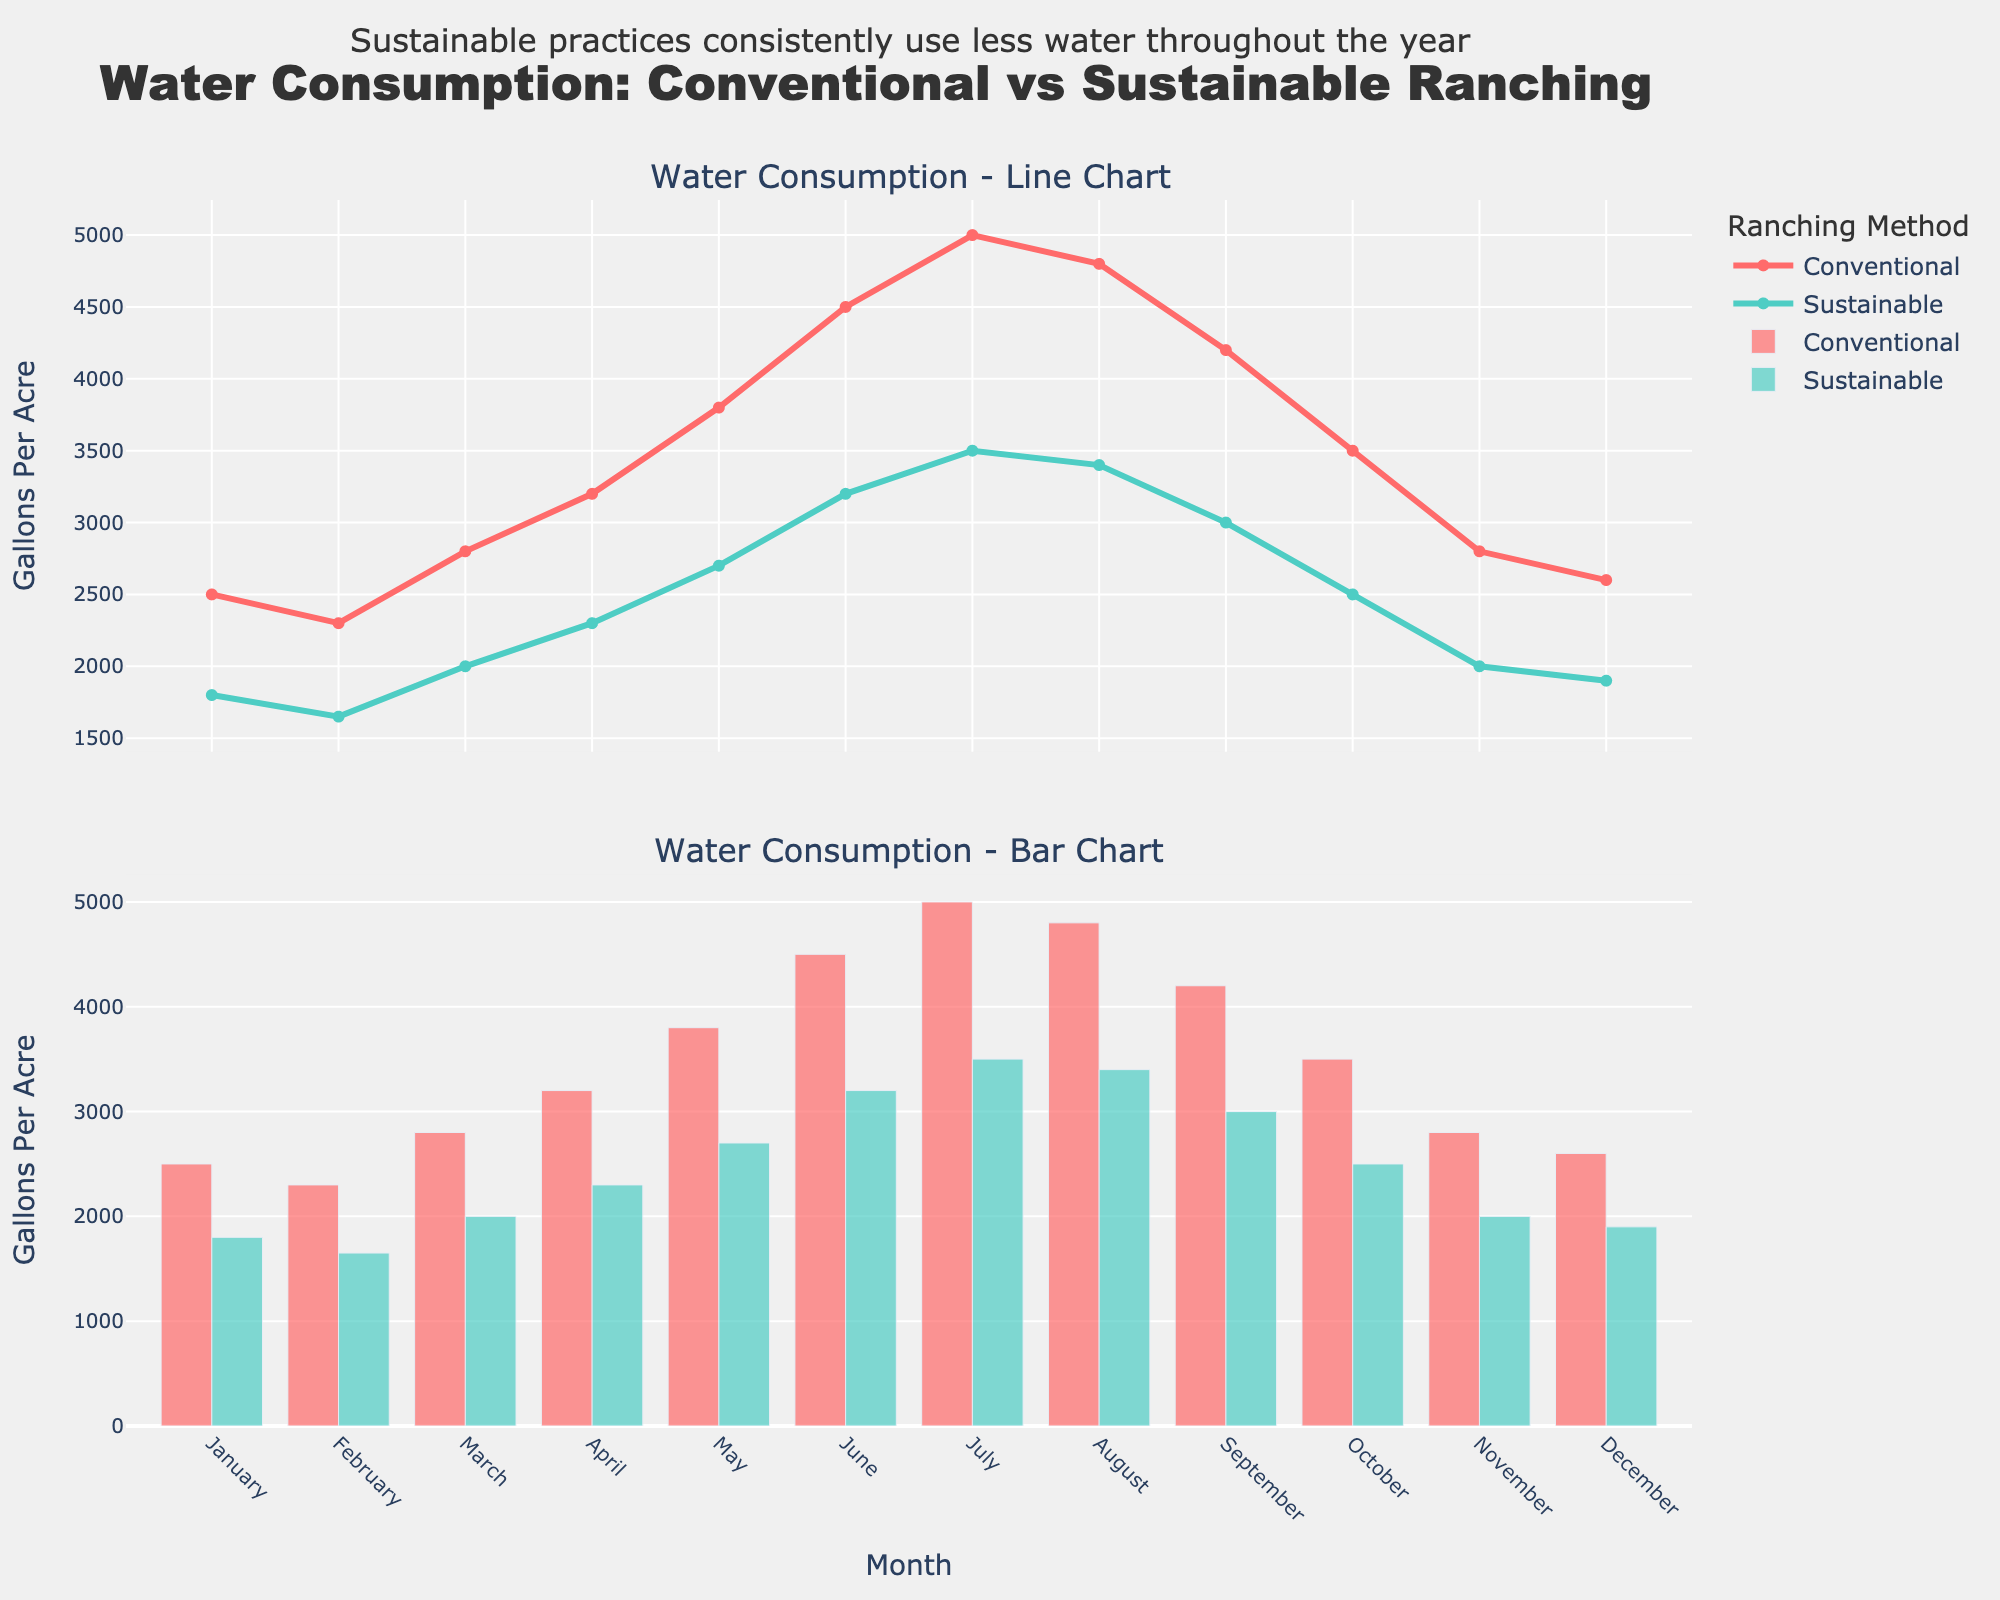What is the title of the plot? The plot title, displayed prominently at the top, reads "Water Consumption: Conventional vs Sustainable Ranching".
Answer: "Water Consumption: Conventional vs Sustainable Ranching" In which month does conventional ranching have the highest water consumption, according to the line chart? By examining the peak points in the line chart, July shows the highest water consumption for conventional ranching.
Answer: July What is the water consumption rate in gallons per acre for sustainable ranching in June, according to the bar chart? Locate the June data in the bar chart for sustainable ranching which shows a water consumption of 3200 gallons per acre.
Answer: 3200 gallons per acre How does the water consumption in January compare between conventional and sustainable ranching? January water consumption for conventional ranching is 2500 gallons per acre, while for sustainable ranching it is 1800 gallons per acre; conventional ranching uses more water.
Answer: Conventional ranching uses more water What is the average water consumption for conventional ranching over the year according to the line chart? Sum the monthly water consumption values for conventional ranching (2500 + 2300 + 2800 + 3200 + 3800 + 4500 + 5000 + 4800 + 4200 + 3500 + 2800 + 2600 = 42000), then divide by the number of months (12). The average is 42000 / 12 = 3500 gallons per acre.
Answer: 3500 gallons per acre What is the decrease in water consumption from March to April in sustainable ranching, according to the line chart? Water consumption decreases from 2000 gallons per acre in March to 2300 gallons per acre in April for sustainable ranching, which means an increase of 300 gallons per acre.
Answer: 300 gallons per acre In which months is the water consumption rate higher for sustainable ranching compared to conventional ranching, according to the bar chart? According to the bar chart, there are no months where sustainable ranching's water consumption exceeds that of conventional ranching.
Answer: None Which ranching method shows a more consistent water conservation pattern throughout the year, according to the line chart? The sustainable ranching line is consistently lower and shows less fluctuation in comparison to conventional ranching, indicating a more consistent conservation pattern.
Answer: Sustainable ranching Comparing the bar charts, in which month is the gap between conventional and sustainable water consumption the smallest? Observing the bar charts, the smallest gap appears in January, where both bars are closest in height with conventional at 2500 and sustainable at 1800 gallons per acre.
Answer: January By how much does the water consumption in December differ between conventional and sustainable ranching, according to the line chart? The difference in December is calculated by subtracting the sustainable rate (1900 gallons per acre) from the conventional rate (2600 gallons per acre), resulting in a difference of 700 gallons per acre.
Answer: 700 gallons per acre 